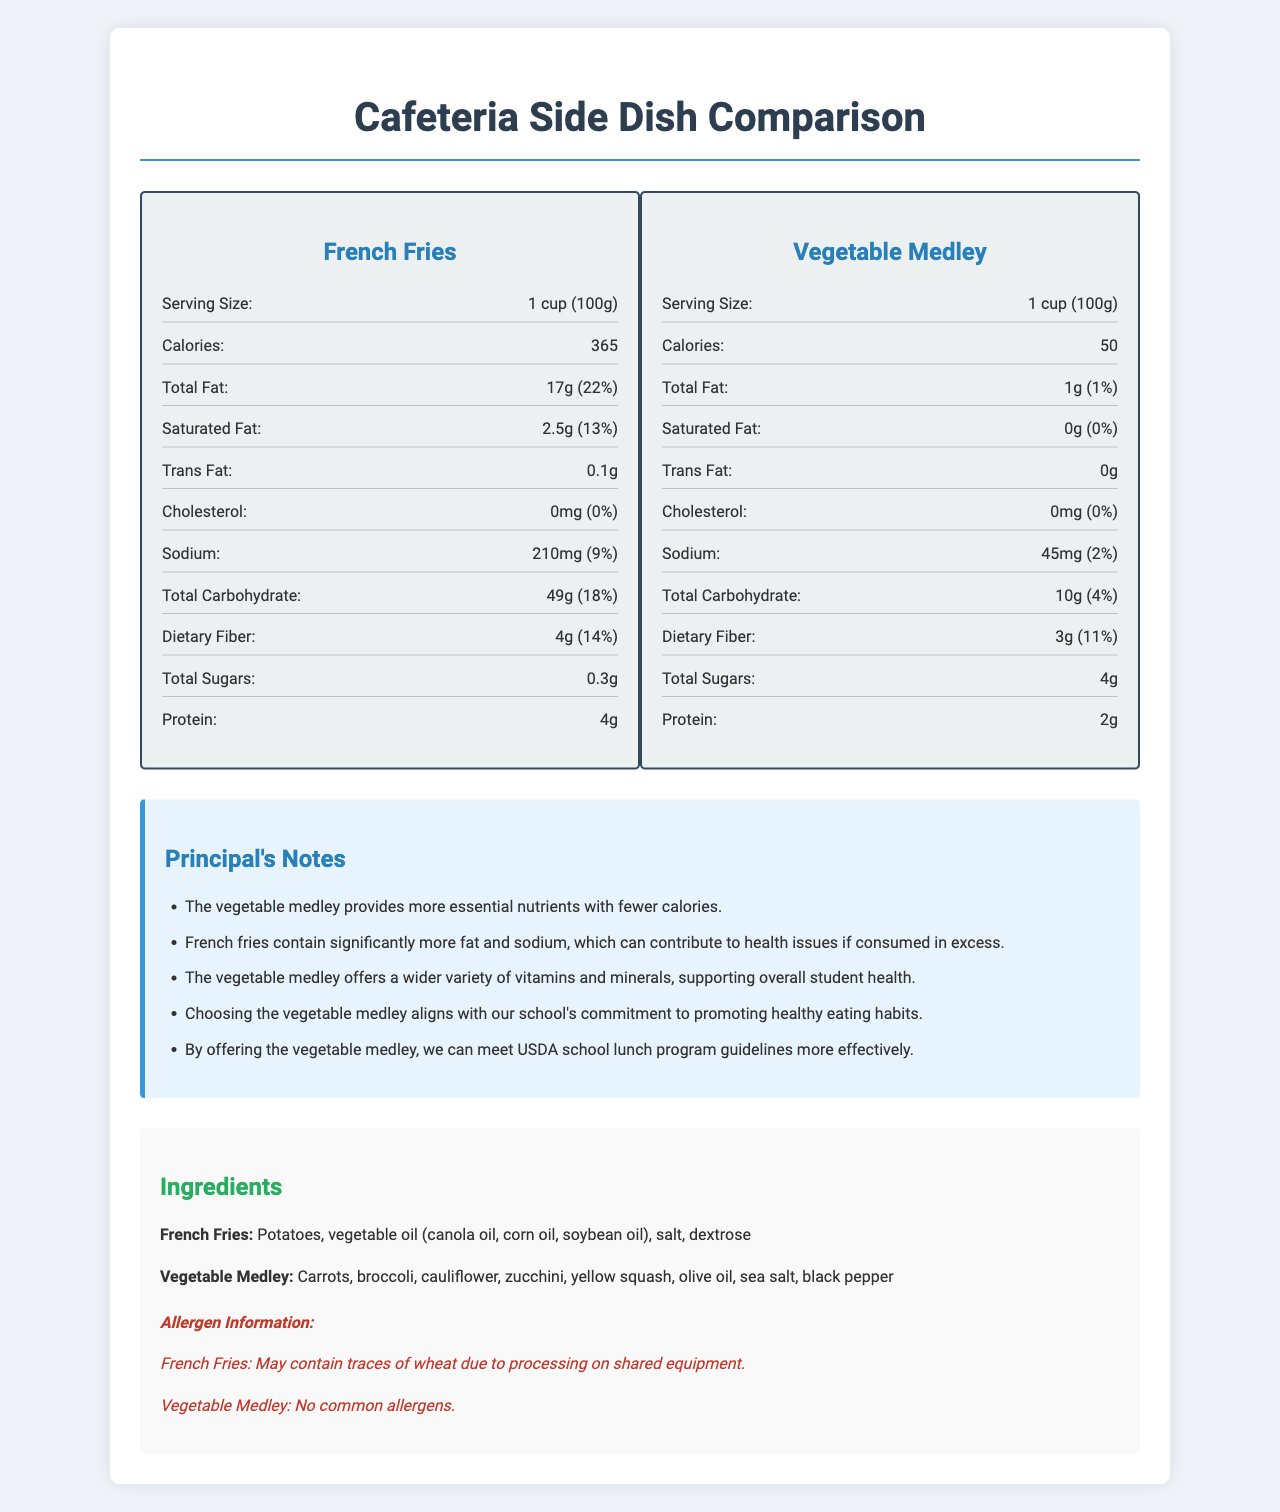1. What is the serving size for both french fries and vegetable medley? The serving size for both items is specified as "1 cup (100g)" in the document.
Answer: 1 cup (100g) 2. How many calories are in a serving of french fries? The document states that french fries have 365 calories per serving.
Answer: 365 3. What percentage of daily value for total fat does the vegetable medley provide? The document notes that the vegetable medley provides 1% of the daily value for total fat.
Answer: 1% 4. What is the amount of dietary fiber in a serving of french fries? The document shows that french fries contain 4 grams of dietary fiber per serving.
Answer: 4 grams 5. Does french fries contain cholesterol? The document specifies that french fries have 0 milligrams of cholesterol, indicating they do not contain cholesterol.
Answer: No 6. What are the allergens for french fries? A. Peanuts B. Wheat C. Dairy D. Gluten According to the document, french fries may contain traces of wheat due to processing on shared equipment.
Answer: B 7. Which side dish provides more potassium? 1. French fries 2. Vegetable medley 3. Both provide the same amount 4. Cannot be determined The document states that french fries have 620 milligrams of potassium, whereas the vegetable medley has 320 milligrams.
Answer: 1 8. Are there any common allergens in the vegetable medley? The document mentions that the vegetable medley contains no common allergens.
Answer: No 9. Which side dish aligns more with promoting healthy eating habits according to the principal's notes? The principal's notes emphasize the advantages of the vegetable medley, including providing essential nutrients and supporting healthy eating habits.
Answer: Vegetable Medley 10. Do the french fries contain added sugars? The document indicates that french fries have 0 grams of added sugars.
Answer: No 11. Which side dish has a higher total carbohydrate content? The document shows that french fries have 49 grams of total carbohydrates, while the vegetable medley has 10 grams.
Answer: French Fries 12. In terms of calories, how much less is the vegetable medley compared to french fries? A. 300 calories B. 150 calories C. 200 calories D. 315 calories E. 50 calories The vegetable medley has 50 calories, while french fries have 365 calories, making the difference 315 calories.
Answer: D 13. What is the main purpose of this document? The document provides detailed nutritional information for both items and includes principal notes emphasizing the health benefits of choosing the vegetable medley over the french fries.
Answer: To compare the nutritional value of french fries and vegetable medley as cafeteria side dishes and advocate for healthier food choices. 14. Which side dish has a higher amount of protein? The document indicates that french fries have 4 grams of protein per serving, whereas the vegetable medley has 2 grams.
Answer: French Fries 15. How many grams of saturated fat do the french fries contain? The document specifies that french fries contain 2.5 grams of saturated fat per serving.
Answer: 2.5 grams 16. Can we determine the exact ingredients used to prepare the vegetables in the vegetable medley? The document lists the ingredients of the vegetable medley, including carrots, broccoli, cauliflower, zucchini, yellow squash, olive oil, sea salt, and black pepper.
Answer: Yes 17. What is the total fiber daily value percentage for the vegetable medley? The document shows that the dietary fiber content of the vegetable medley contributes to 11% of the daily value.
Answer: 11% 18. Is the preparation method of the french fries mentioned in the document? The document does not mention how the french fries are prepared; it only lists the ingredients and nutritional information.
Answer: No 19. Which side dish has lower sodium content? The document shows that the vegetable medley has 45 milligrams of sodium, whereas french fries have 210 milligrams.
Answer: Vegetable Medley 20. What are the principal’s concerns regarding french fries? The principal notes that french fries contain significantly more fat and sodium which can contribute to health issues if consumed in excess.
Answer: High fat and sodium content, contributing to health issues 